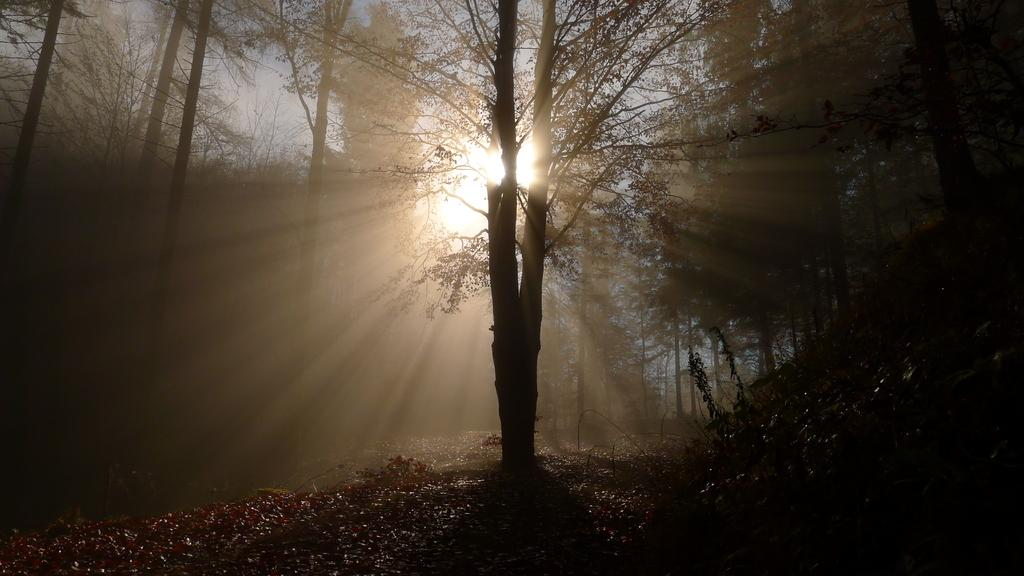What event is taking place in the image? The image depicts a sunrise. Where is the sunrise occurring? The sunrise is in a forest setting. What can be observed about the trees in the forest? There are tall trees in the forest. How is the sun positioned in relation to the trees? The sun is rising from between one of the trees. What type of polish is being applied to the wire in the image? There is no wire or polish present in the image; it depicts a sunrise in a forest setting. 